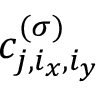Convert formula to latex. <formula><loc_0><loc_0><loc_500><loc_500>c _ { j , i _ { x } , i _ { y } } ^ { ( \sigma ) }</formula> 